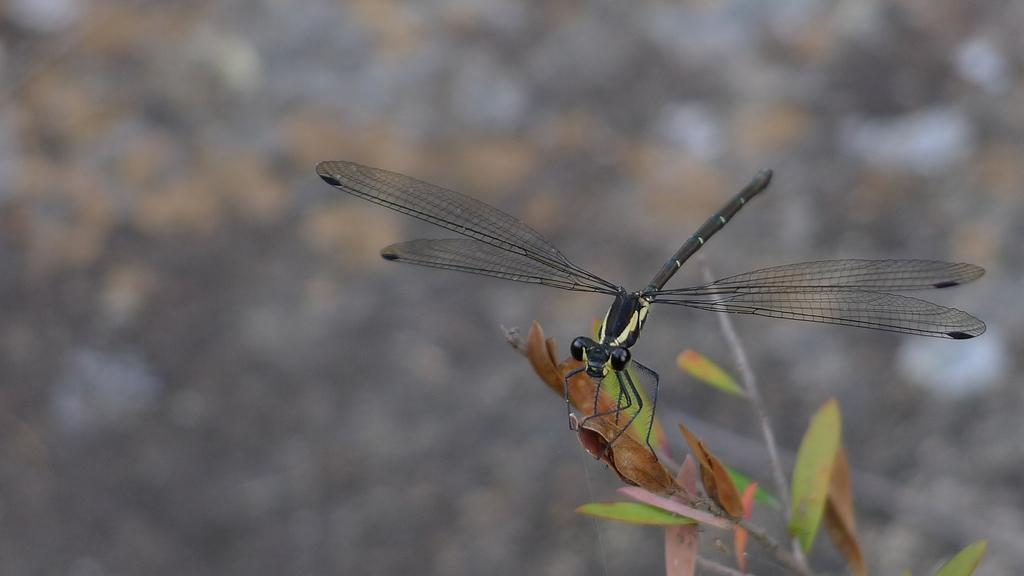What insect is present in the image? There is a dragonfly in the image. Where is the dragonfly located? The dragonfly is on a plant. Can you describe the background of the image? The background of the image is blurred. What type of tree can be seen in the dragonfly's throat in the image? There is no tree or dragonfly's throat present in the image; it features a dragonfly on a plant with a blurred background. 